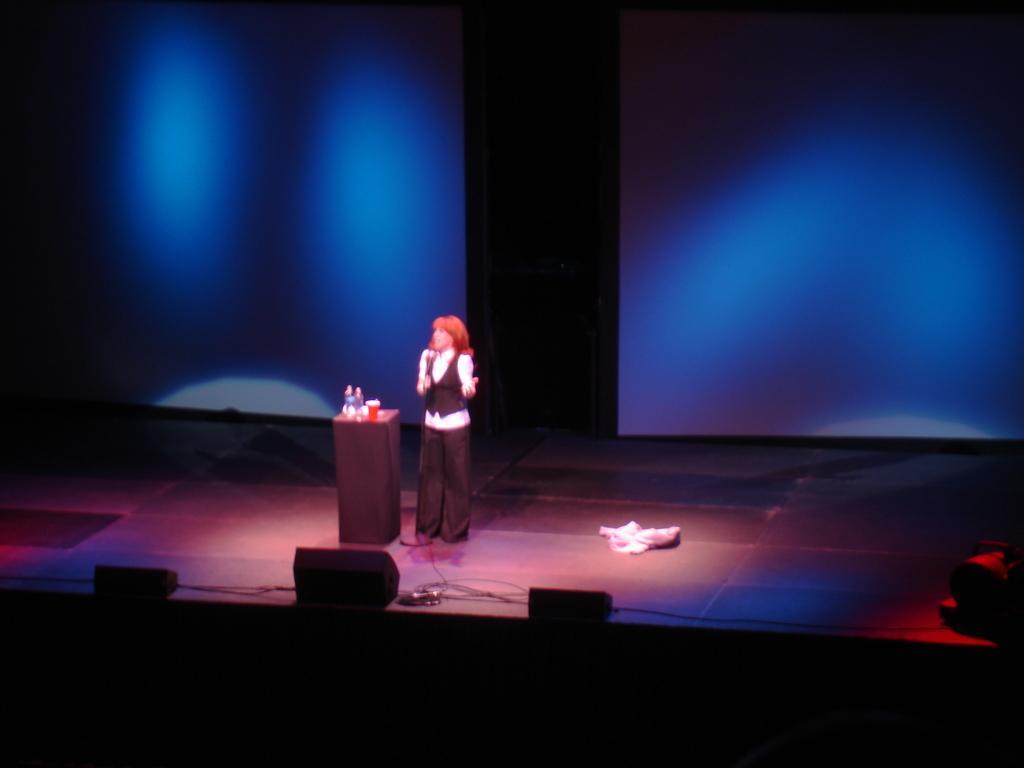Could you give a brief overview of what you see in this image? Here in this picture we can see a woman standing on a stage and speaking something in the microphone present in his hand and beside her we can see a table, on which we can see a bottle and a glass present and behind her we can see a curtain present and in the front we can see lights present over there. 